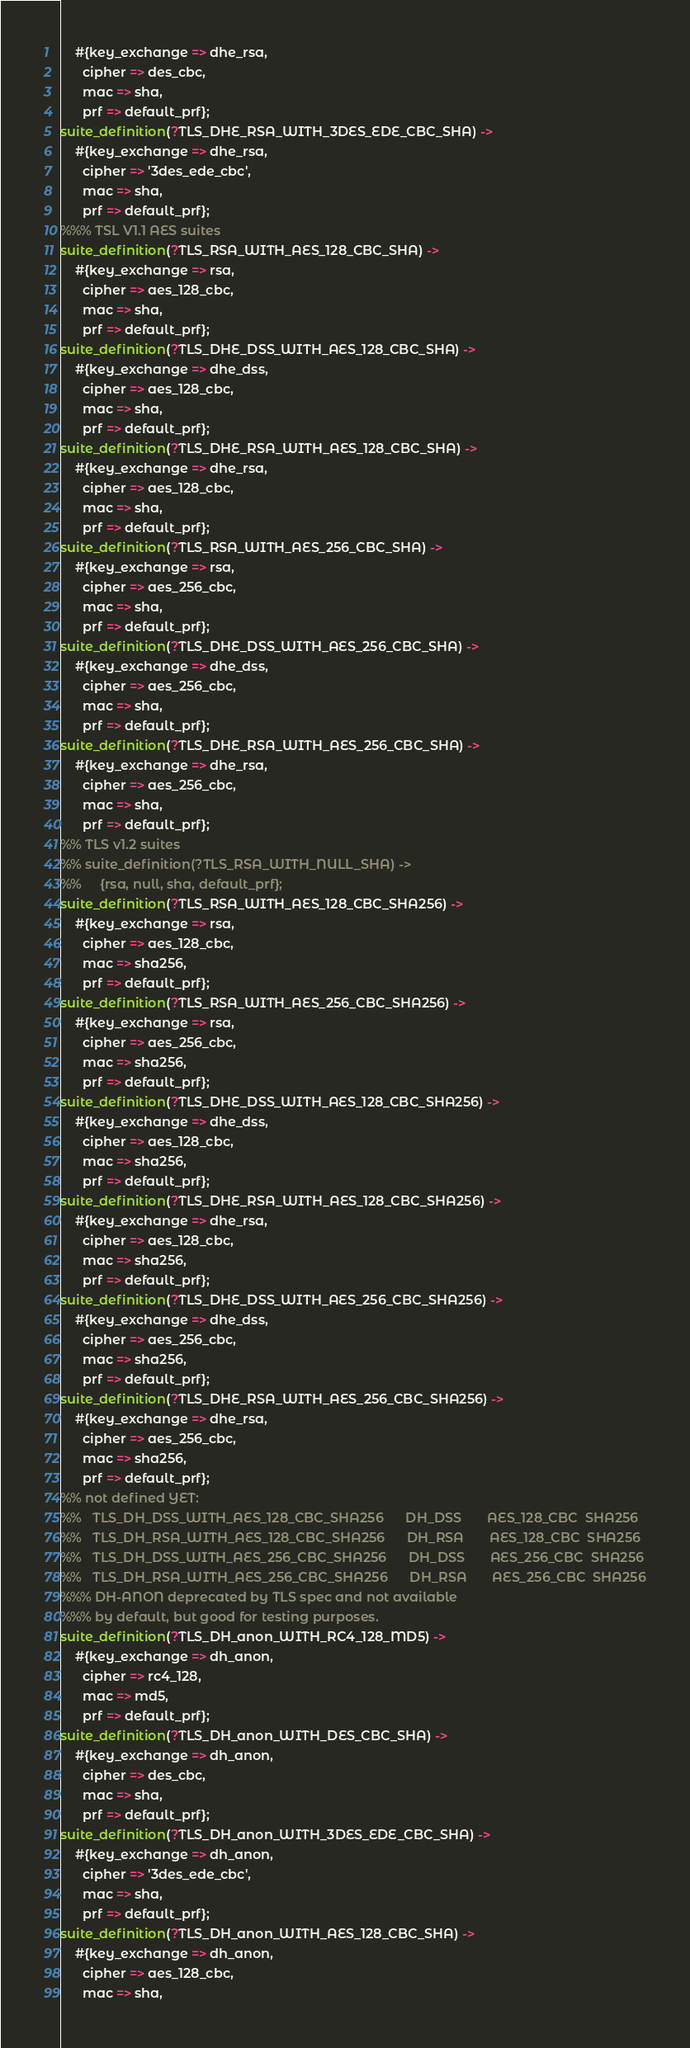Convert code to text. <code><loc_0><loc_0><loc_500><loc_500><_Erlang_>    #{key_exchange => dhe_rsa, 
      cipher => des_cbc, 
      mac => sha, 
      prf => default_prf};
suite_definition(?TLS_DHE_RSA_WITH_3DES_EDE_CBC_SHA) ->
    #{key_exchange => dhe_rsa, 
      cipher => '3des_ede_cbc', 
      mac => sha, 
      prf => default_prf};
%%% TSL V1.1 AES suites
suite_definition(?TLS_RSA_WITH_AES_128_CBC_SHA) -> 
    #{key_exchange => rsa,
      cipher => aes_128_cbc, 
      mac => sha, 
      prf => default_prf};
suite_definition(?TLS_DHE_DSS_WITH_AES_128_CBC_SHA) ->
    #{key_exchange => dhe_dss, 
      cipher => aes_128_cbc, 
      mac => sha, 
      prf => default_prf};
suite_definition(?TLS_DHE_RSA_WITH_AES_128_CBC_SHA) ->
    #{key_exchange => dhe_rsa, 
      cipher => aes_128_cbc, 
      mac => sha, 
      prf => default_prf};
suite_definition(?TLS_RSA_WITH_AES_256_CBC_SHA) -> 
    #{key_exchange => rsa, 
      cipher => aes_256_cbc, 
      mac => sha, 
      prf => default_prf};
suite_definition(?TLS_DHE_DSS_WITH_AES_256_CBC_SHA) ->
    #{key_exchange => dhe_dss, 
      cipher => aes_256_cbc, 
      mac => sha, 
      prf => default_prf};
suite_definition(?TLS_DHE_RSA_WITH_AES_256_CBC_SHA) ->
    #{key_exchange => dhe_rsa, 
      cipher => aes_256_cbc, 
      mac => sha, 
      prf => default_prf};
%% TLS v1.2 suites
%% suite_definition(?TLS_RSA_WITH_NULL_SHA) ->
%%     {rsa, null, sha, default_prf};
suite_definition(?TLS_RSA_WITH_AES_128_CBC_SHA256) ->
    #{key_exchange => rsa, 
      cipher => aes_128_cbc, 
      mac => sha256, 
      prf => default_prf};
suite_definition(?TLS_RSA_WITH_AES_256_CBC_SHA256) ->
    #{key_exchange => rsa, 
      cipher => aes_256_cbc, 
      mac => sha256, 
      prf => default_prf};
suite_definition(?TLS_DHE_DSS_WITH_AES_128_CBC_SHA256) ->
    #{key_exchange => dhe_dss, 
      cipher => aes_128_cbc, 
      mac => sha256, 
      prf => default_prf};
suite_definition(?TLS_DHE_RSA_WITH_AES_128_CBC_SHA256) ->
    #{key_exchange => dhe_rsa, 
      cipher => aes_128_cbc, 
      mac => sha256, 
      prf => default_prf};
suite_definition(?TLS_DHE_DSS_WITH_AES_256_CBC_SHA256) ->
    #{key_exchange => dhe_dss, 
      cipher => aes_256_cbc, 
      mac => sha256, 
      prf => default_prf};
suite_definition(?TLS_DHE_RSA_WITH_AES_256_CBC_SHA256) ->
    #{key_exchange => dhe_rsa, 
      cipher => aes_256_cbc, 
      mac => sha256, 
      prf => default_prf};
%% not defined YET:
%%   TLS_DH_DSS_WITH_AES_128_CBC_SHA256      DH_DSS       AES_128_CBC  SHA256
%%   TLS_DH_RSA_WITH_AES_128_CBC_SHA256      DH_RSA       AES_128_CBC  SHA256
%%   TLS_DH_DSS_WITH_AES_256_CBC_SHA256      DH_DSS       AES_256_CBC  SHA256
%%   TLS_DH_RSA_WITH_AES_256_CBC_SHA256      DH_RSA       AES_256_CBC  SHA256
%%% DH-ANON deprecated by TLS spec and not available
%%% by default, but good for testing purposes.
suite_definition(?TLS_DH_anon_WITH_RC4_128_MD5) ->
    #{key_exchange => dh_anon, 
      cipher => rc4_128, 
      mac => md5, 
      prf => default_prf};
suite_definition(?TLS_DH_anon_WITH_DES_CBC_SHA) ->
    #{key_exchange => dh_anon, 
      cipher => des_cbc, 
      mac => sha, 
      prf => default_prf};
suite_definition(?TLS_DH_anon_WITH_3DES_EDE_CBC_SHA) ->
    #{key_exchange => dh_anon, 
      cipher => '3des_ede_cbc', 
      mac => sha, 
      prf => default_prf};
suite_definition(?TLS_DH_anon_WITH_AES_128_CBC_SHA) ->
    #{key_exchange => dh_anon, 
      cipher => aes_128_cbc, 
      mac => sha, </code> 